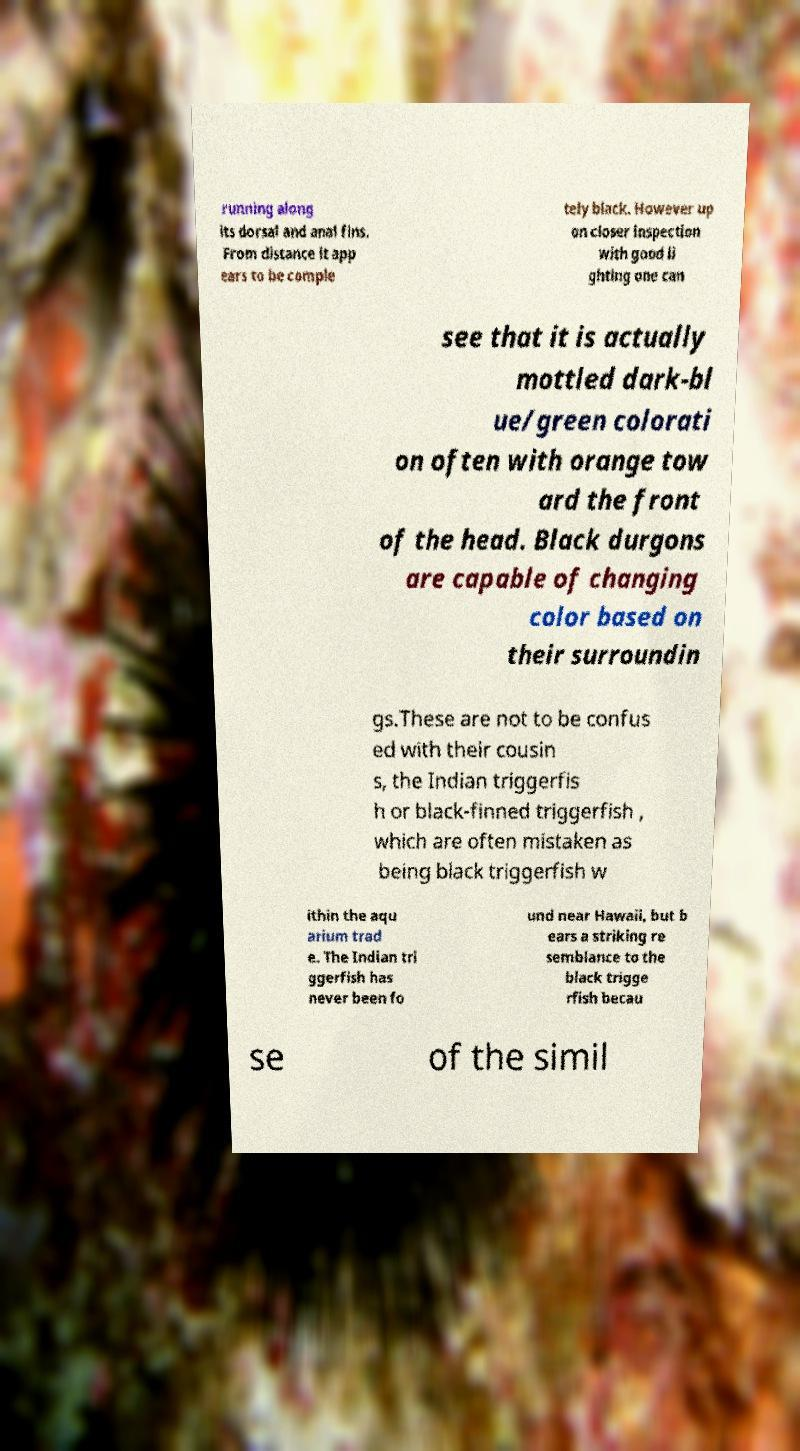For documentation purposes, I need the text within this image transcribed. Could you provide that? running along its dorsal and anal fins. From distance it app ears to be comple tely black. However up on closer inspection with good li ghting one can see that it is actually mottled dark-bl ue/green colorati on often with orange tow ard the front of the head. Black durgons are capable of changing color based on their surroundin gs.These are not to be confus ed with their cousin s, the Indian triggerfis h or black-finned triggerfish , which are often mistaken as being black triggerfish w ithin the aqu arium trad e. The Indian tri ggerfish has never been fo und near Hawaii, but b ears a striking re semblance to the black trigge rfish becau se of the simil 